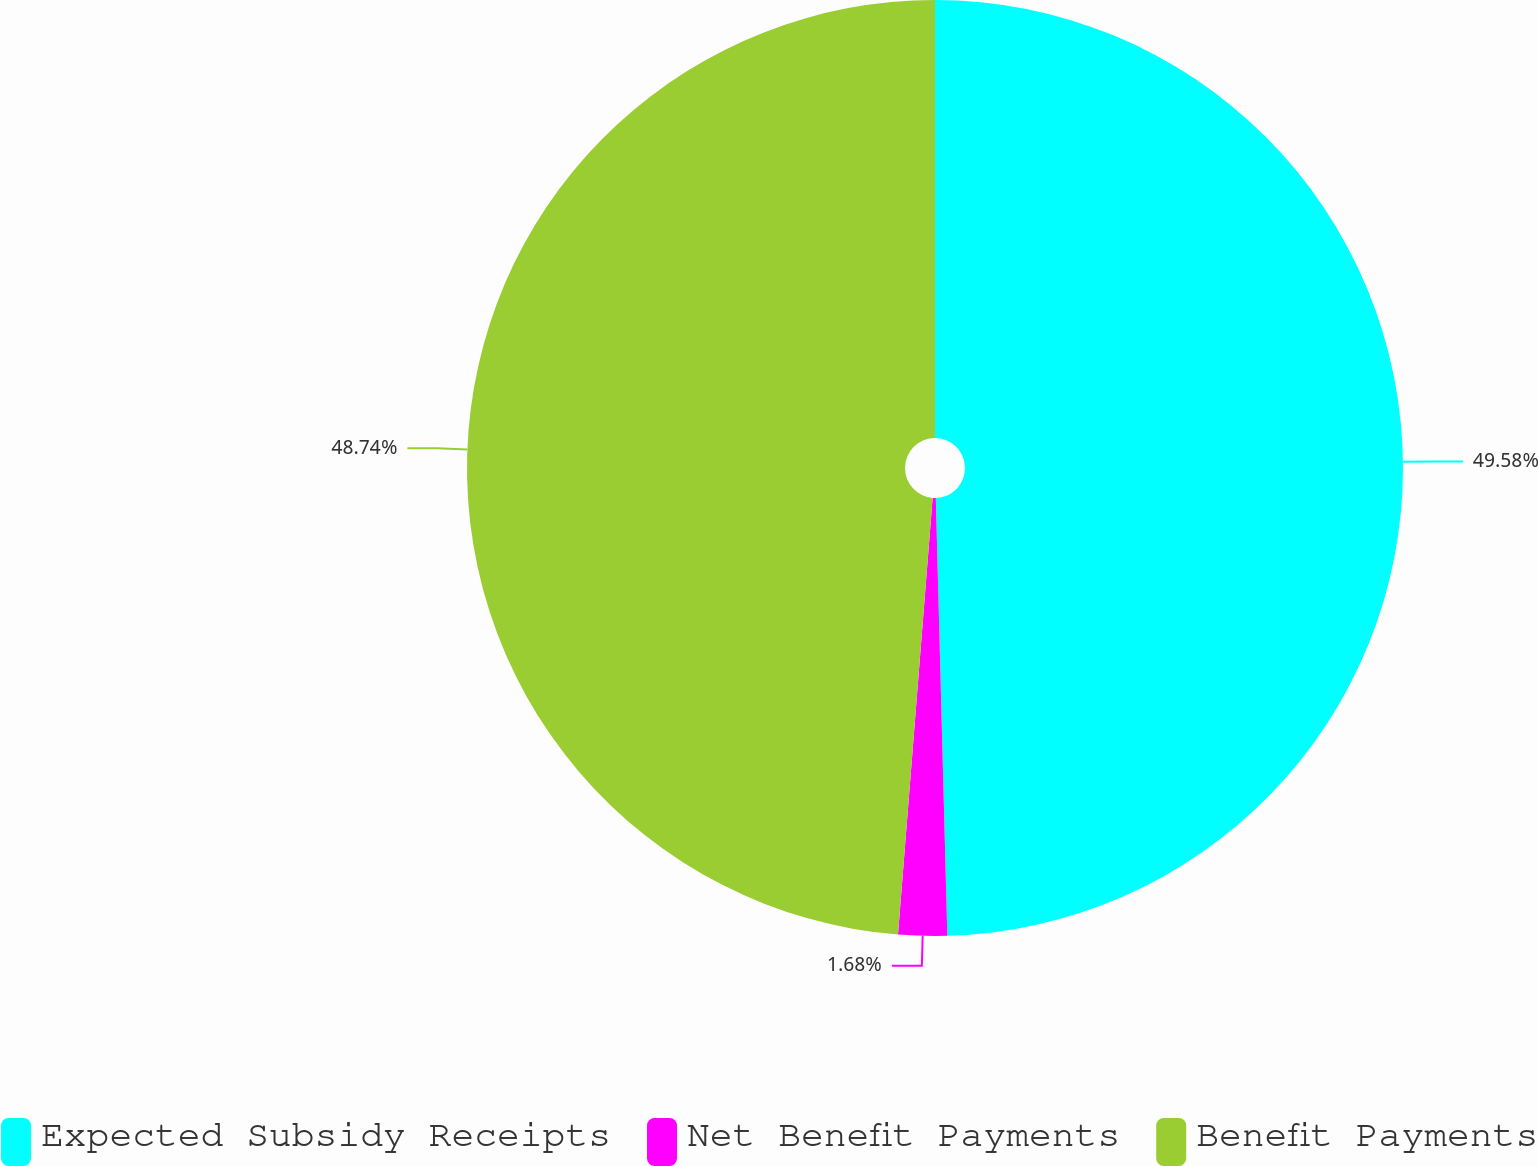Convert chart to OTSL. <chart><loc_0><loc_0><loc_500><loc_500><pie_chart><fcel>Expected Subsidy Receipts<fcel>Net Benefit Payments<fcel>Benefit Payments<nl><fcel>49.58%<fcel>1.68%<fcel>48.74%<nl></chart> 